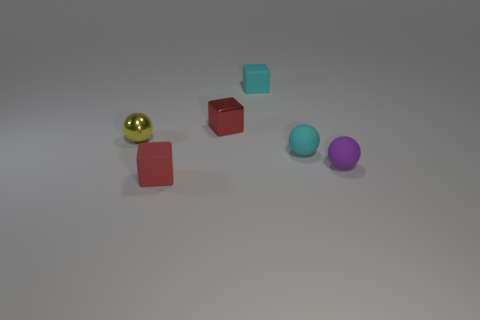Add 1 yellow objects. How many objects exist? 7 Add 2 tiny matte objects. How many tiny matte objects are left? 6 Add 3 red metallic cylinders. How many red metallic cylinders exist? 3 Subtract 0 yellow cubes. How many objects are left? 6 Subtract all tiny yellow metal balls. Subtract all rubber things. How many objects are left? 1 